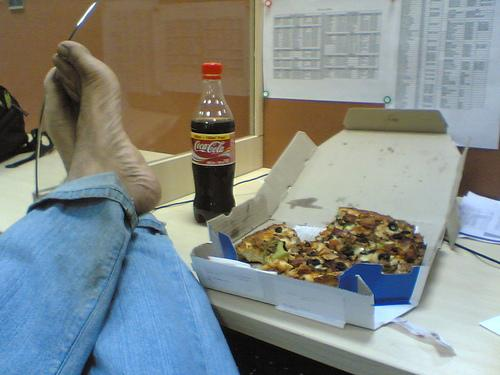What are the black things on the person's food? Please explain your reasoning. black olives. They are olives on a pizza. 